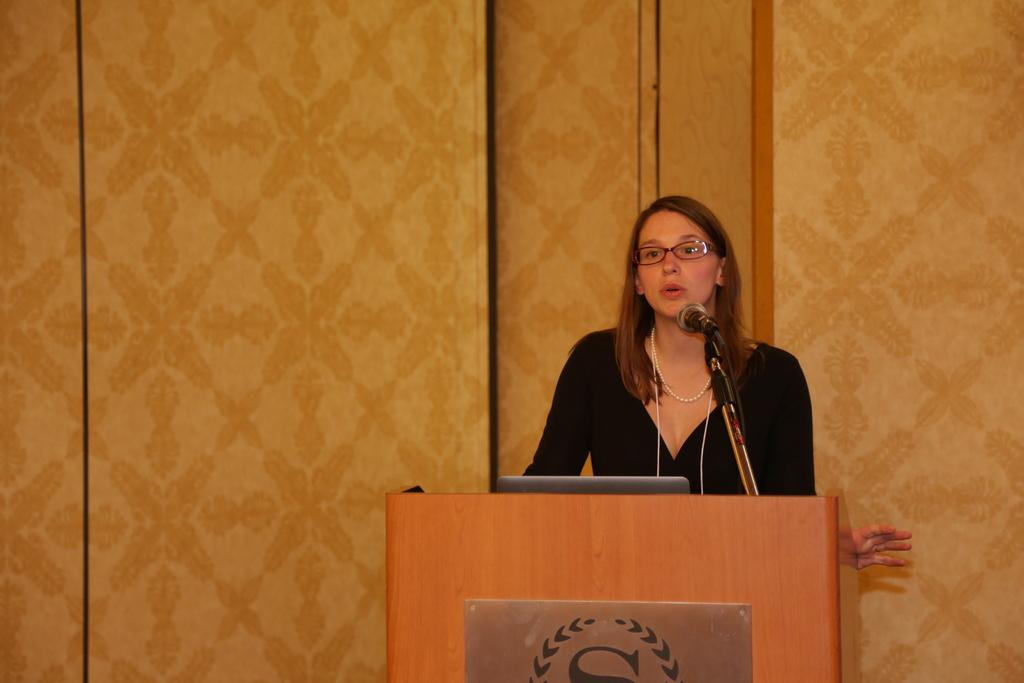What is the person in the image doing? The person is standing in front of a podium. What is the person likely using to communicate with the audience? There is a microphone in the image, which suggests it is being used for amplifying the person's voice. What electronic device can be seen in the image? It appears to be a laptop in the image. What type of wall is visible in the background? There is a wooden wall in the background. How many beds are visible in the image? There are no beds present in the image. 